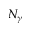<formula> <loc_0><loc_0><loc_500><loc_500>N _ { \gamma }</formula> 